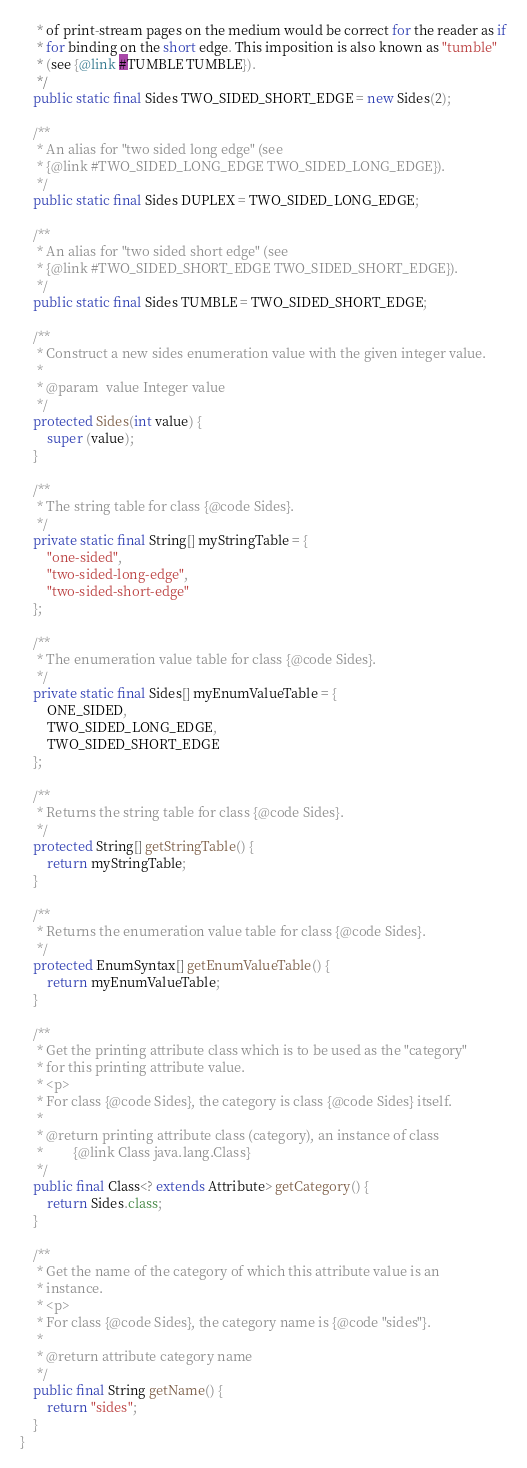Convert code to text. <code><loc_0><loc_0><loc_500><loc_500><_Java_>     * of print-stream pages on the medium would be correct for the reader as if
     * for binding on the short edge. This imposition is also known as "tumble"
     * (see {@link #TUMBLE TUMBLE}).
     */
    public static final Sides TWO_SIDED_SHORT_EDGE = new Sides(2);

    /**
     * An alias for "two sided long edge" (see
     * {@link #TWO_SIDED_LONG_EDGE TWO_SIDED_LONG_EDGE}).
     */
    public static final Sides DUPLEX = TWO_SIDED_LONG_EDGE;

    /**
     * An alias for "two sided short edge" (see
     * {@link #TWO_SIDED_SHORT_EDGE TWO_SIDED_SHORT_EDGE}).
     */
    public static final Sides TUMBLE = TWO_SIDED_SHORT_EDGE;

    /**
     * Construct a new sides enumeration value with the given integer value.
     *
     * @param  value Integer value
     */
    protected Sides(int value) {
        super (value);
    }

    /**
     * The string table for class {@code Sides}.
     */
    private static final String[] myStringTable = {
        "one-sided",
        "two-sided-long-edge",
        "two-sided-short-edge"
    };

    /**
     * The enumeration value table for class {@code Sides}.
     */
    private static final Sides[] myEnumValueTable = {
        ONE_SIDED,
        TWO_SIDED_LONG_EDGE,
        TWO_SIDED_SHORT_EDGE
    };

    /**
     * Returns the string table for class {@code Sides}.
     */
    protected String[] getStringTable() {
        return myStringTable;
    }

    /**
     * Returns the enumeration value table for class {@code Sides}.
     */
    protected EnumSyntax[] getEnumValueTable() {
        return myEnumValueTable;
    }

    /**
     * Get the printing attribute class which is to be used as the "category"
     * for this printing attribute value.
     * <p>
     * For class {@code Sides}, the category is class {@code Sides} itself.
     *
     * @return printing attribute class (category), an instance of class
     *         {@link Class java.lang.Class}
     */
    public final Class<? extends Attribute> getCategory() {
        return Sides.class;
    }

    /**
     * Get the name of the category of which this attribute value is an
     * instance.
     * <p>
     * For class {@code Sides}, the category name is {@code "sides"}.
     *
     * @return attribute category name
     */
    public final String getName() {
        return "sides";
    }
}
</code> 